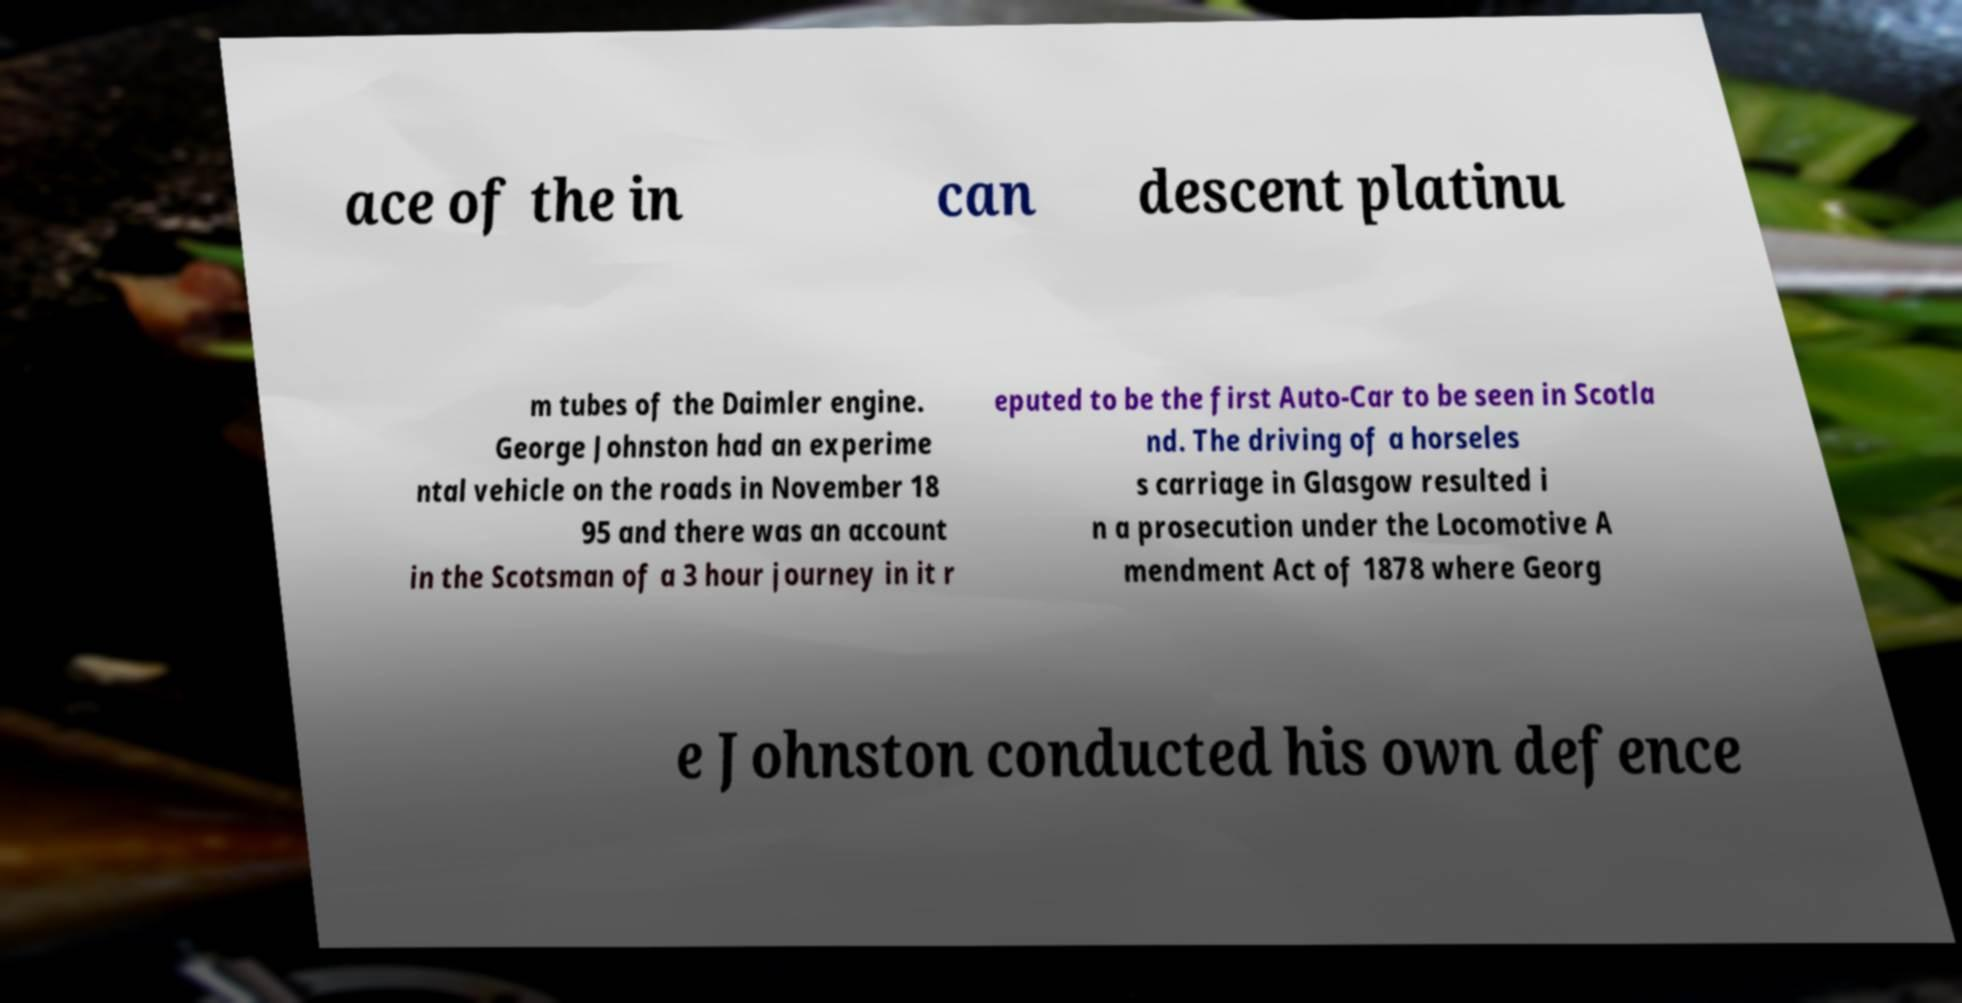There's text embedded in this image that I need extracted. Can you transcribe it verbatim? ace of the in can descent platinu m tubes of the Daimler engine. George Johnston had an experime ntal vehicle on the roads in November 18 95 and there was an account in the Scotsman of a 3 hour journey in it r eputed to be the first Auto-Car to be seen in Scotla nd. The driving of a horseles s carriage in Glasgow resulted i n a prosecution under the Locomotive A mendment Act of 1878 where Georg e Johnston conducted his own defence 